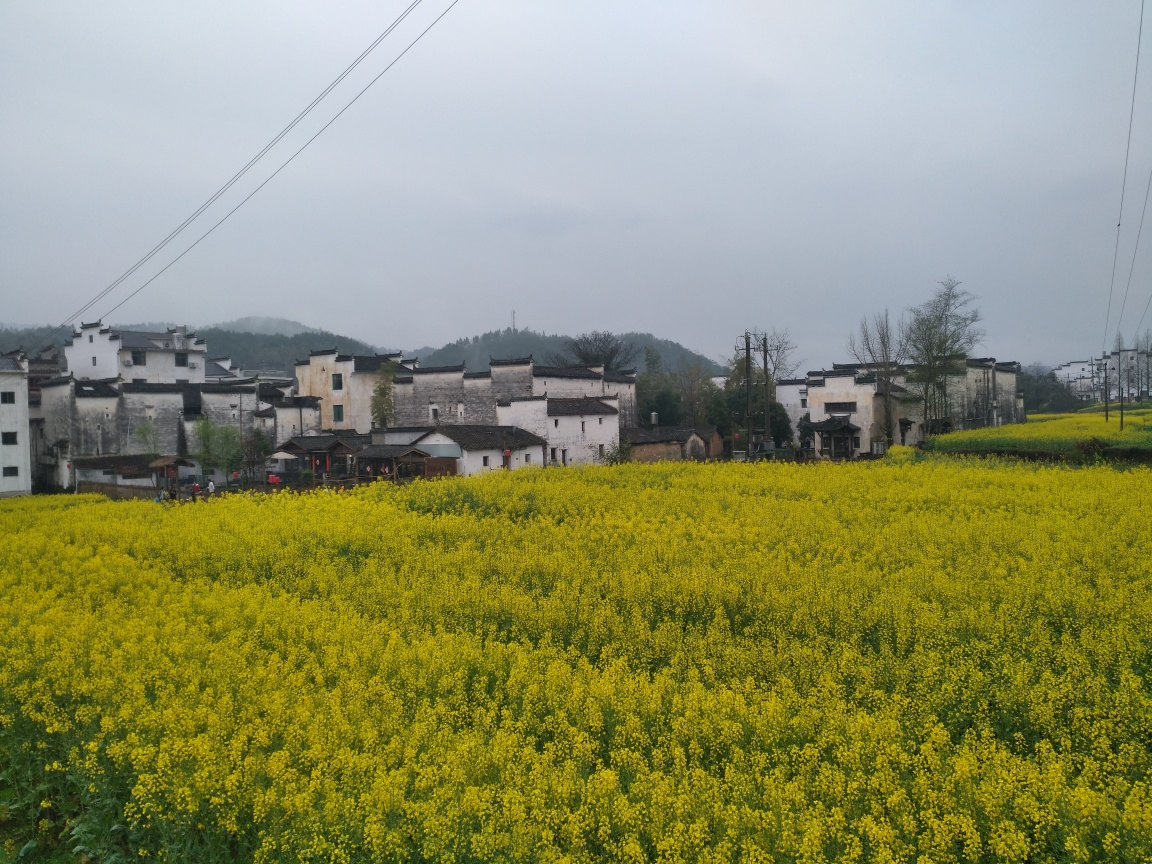What kind of weather does the image suggest? The image suggests overcast and possibly damp weather. The diffuse lighting and absence of shadows indicate that the sun is obscured by clouds. Such conditions often result in soft and even lighting, which can be quite desirable for outdoor photography as it minimizes harsh shadows and bright highlights. 